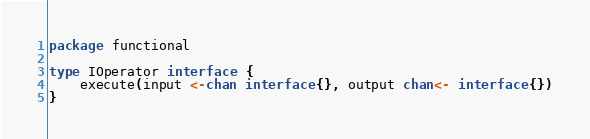Convert code to text. <code><loc_0><loc_0><loc_500><loc_500><_Go_>package functional

type IOperator interface {
	execute(input <-chan interface{}, output chan<- interface{})
}
</code> 